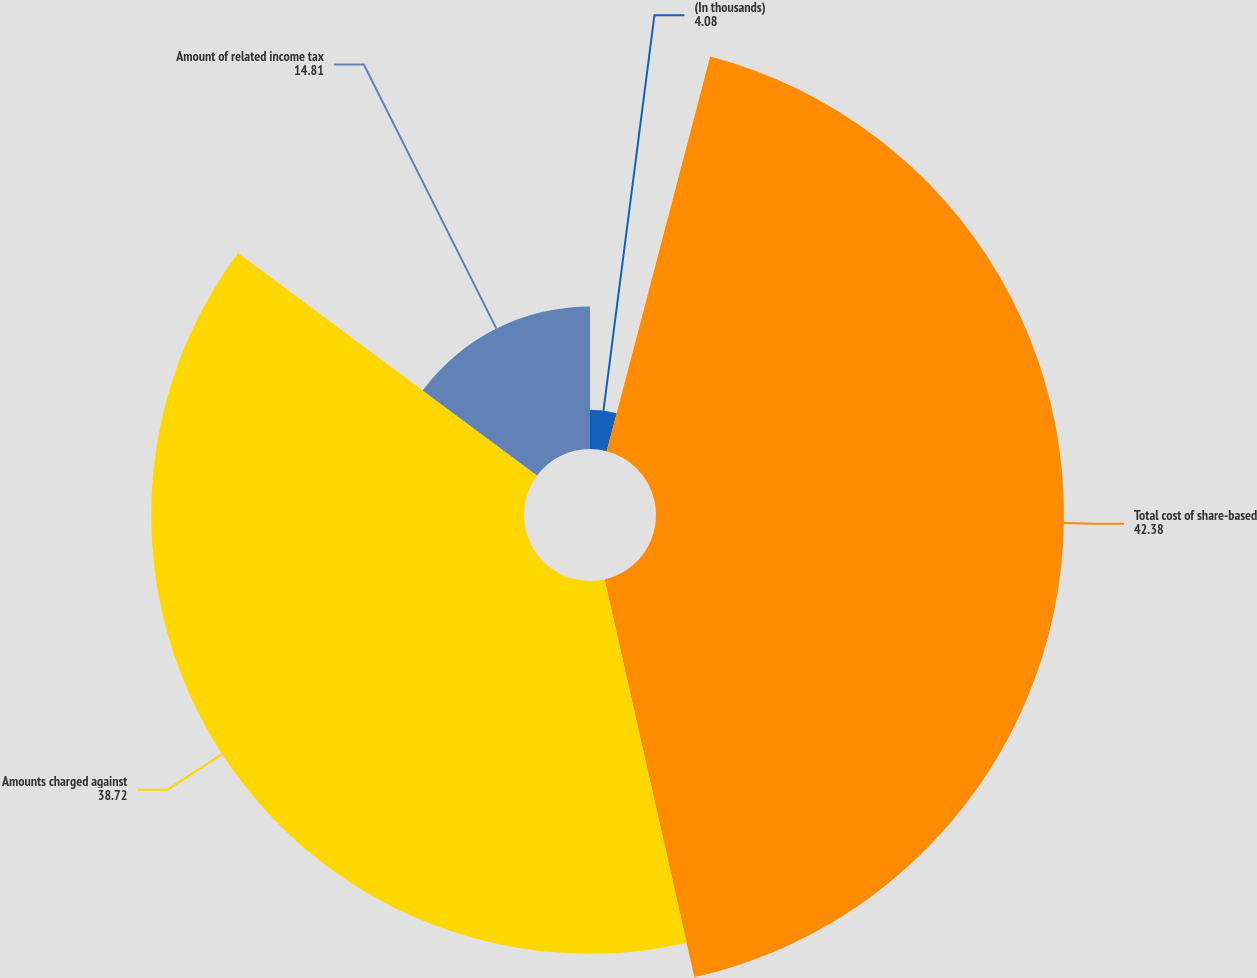Convert chart. <chart><loc_0><loc_0><loc_500><loc_500><pie_chart><fcel>(In thousands)<fcel>Total cost of share-based<fcel>Amounts charged against<fcel>Amount of related income tax<nl><fcel>4.08%<fcel>42.38%<fcel>38.72%<fcel>14.81%<nl></chart> 